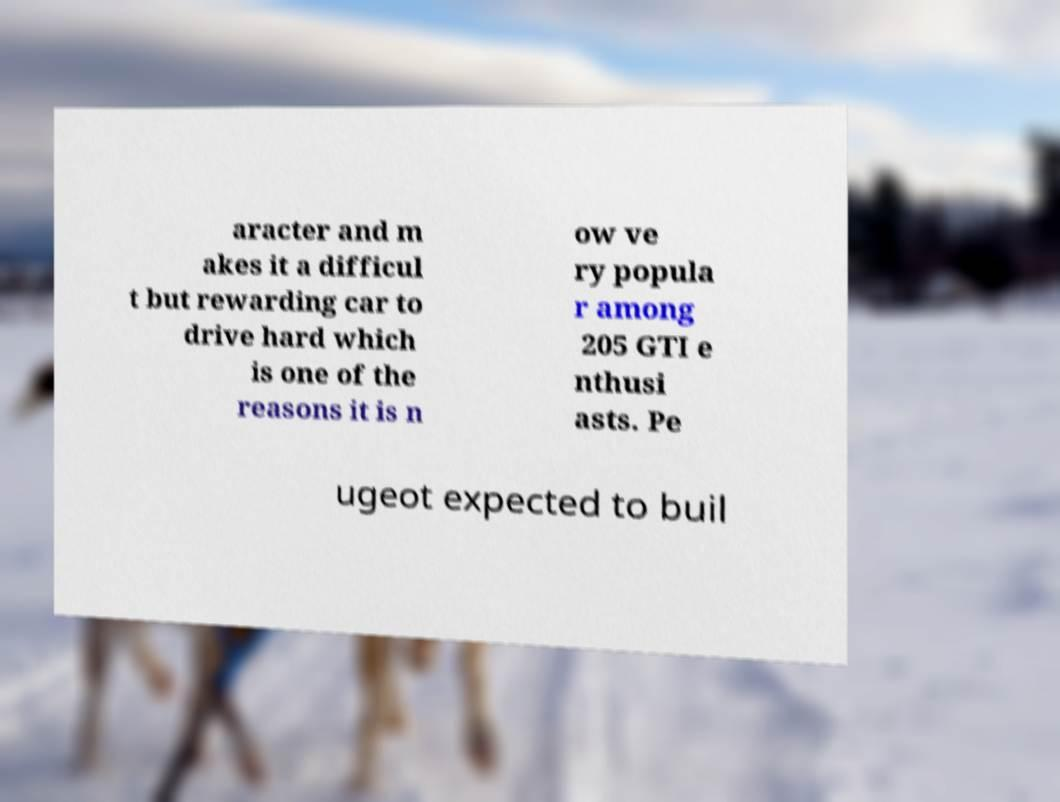What messages or text are displayed in this image? I need them in a readable, typed format. aracter and m akes it a difficul t but rewarding car to drive hard which is one of the reasons it is n ow ve ry popula r among 205 GTI e nthusi asts. Pe ugeot expected to buil 